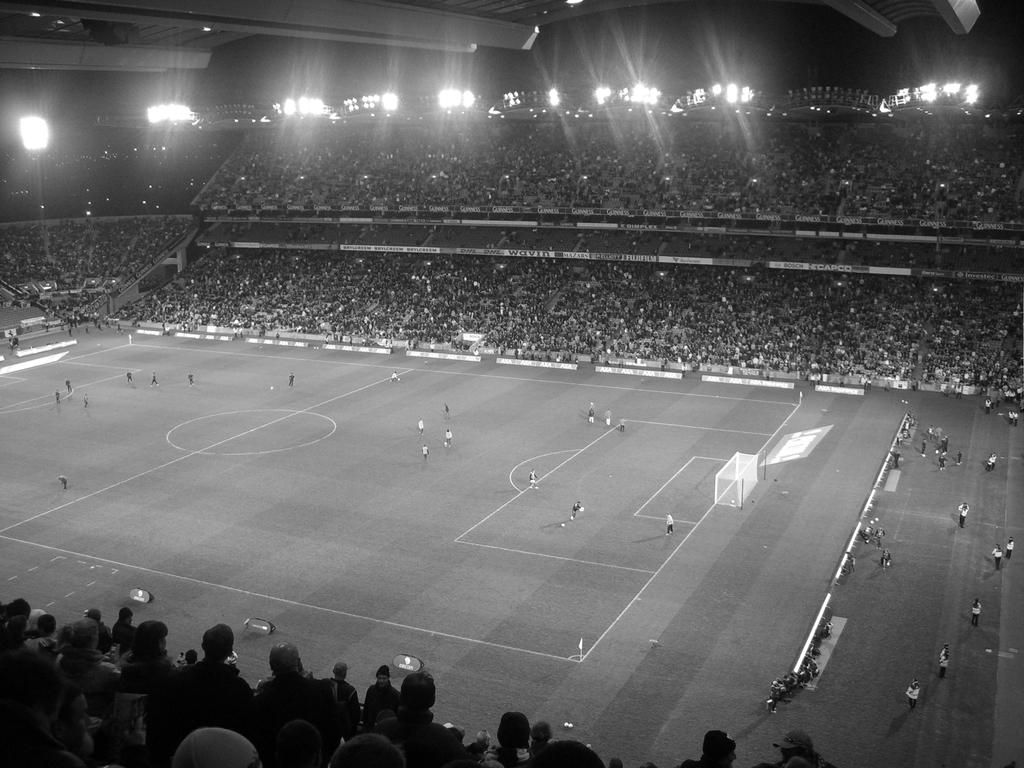What type of structure is visible in the image? There is a stadium in the image. What can be seen inside the stadium? There are people standing in the stadium, and there are audience members present. Can you describe any lighting features in the image? Yes, there is a flood light in the left top corner of the image. Can you touch the store that is visible in the image? There is no store present in the image; it features a stadium with people and a flood light. 